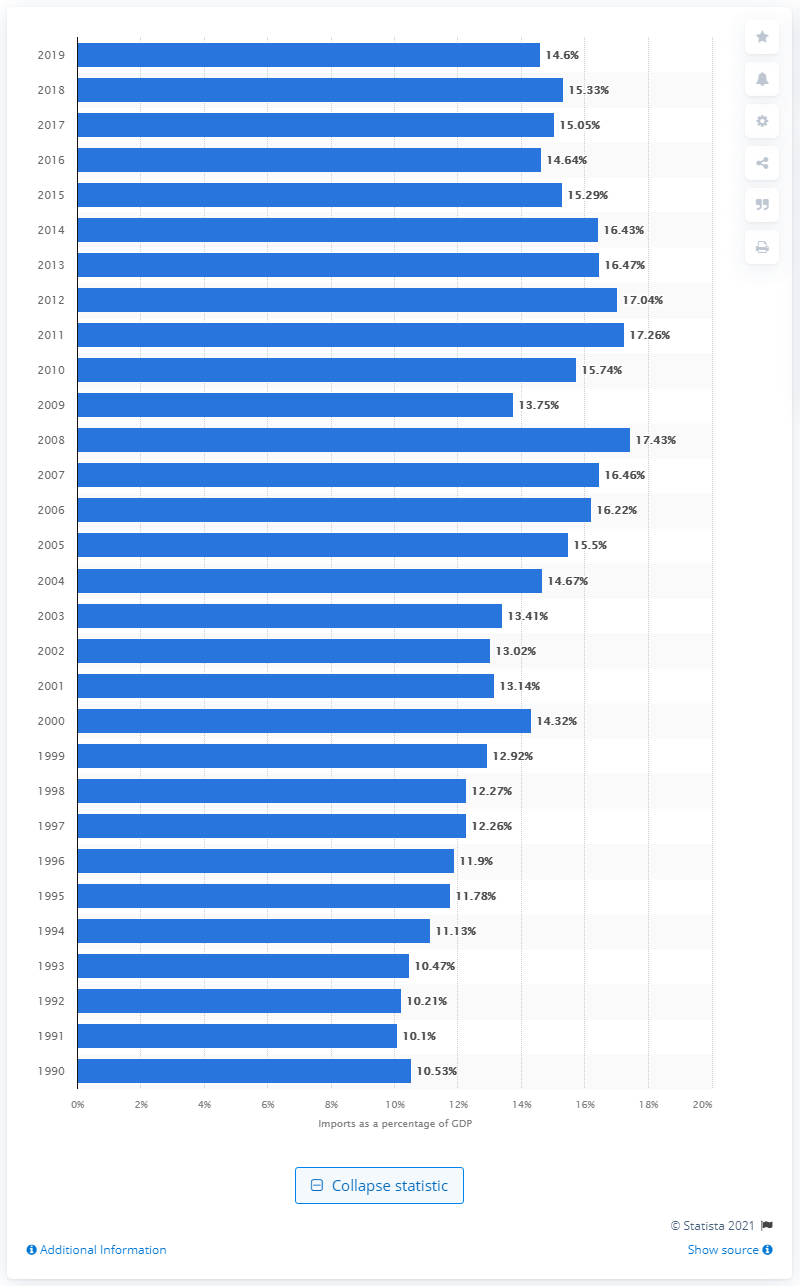List a handful of essential elements in this visual. In 2019, the percentage of imports of goods and services from the United States was 14.6%. 